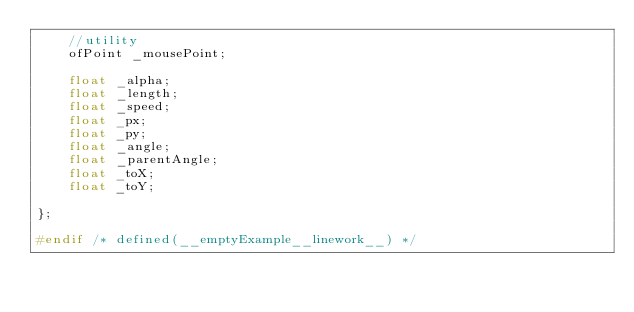Convert code to text. <code><loc_0><loc_0><loc_500><loc_500><_C_>    //utility
    ofPoint _mousePoint;
    
    float _alpha;
    float _length;
    float _speed;
    float _px;
    float _py;
    float _angle;
    float _parentAngle;
    float _toX;
    float _toY;
    
};

#endif /* defined(__emptyExample__linework__) */
</code> 